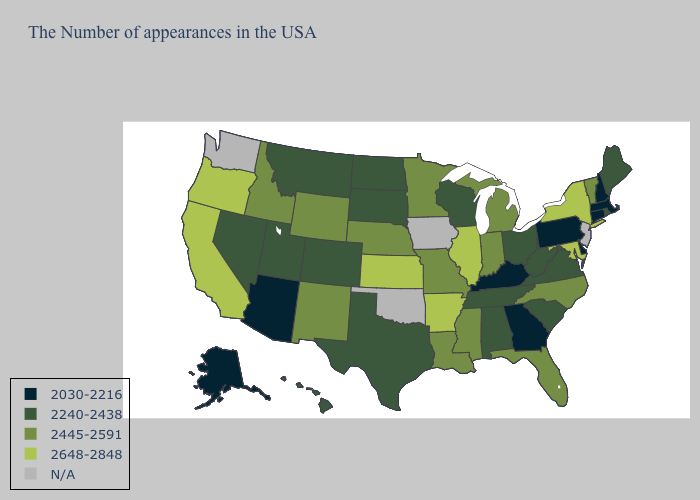What is the value of Arkansas?
Keep it brief. 2648-2848. Does Delaware have the lowest value in the USA?
Be succinct. Yes. Does Pennsylvania have the lowest value in the Northeast?
Write a very short answer. Yes. Which states have the lowest value in the USA?
Write a very short answer. Massachusetts, New Hampshire, Connecticut, Delaware, Pennsylvania, Georgia, Kentucky, Arizona, Alaska. Name the states that have a value in the range 2648-2848?
Concise answer only. New York, Maryland, Illinois, Arkansas, Kansas, California, Oregon. What is the value of Oregon?
Be succinct. 2648-2848. Does Delaware have the lowest value in the South?
Short answer required. Yes. What is the value of Kentucky?
Be succinct. 2030-2216. What is the value of Illinois?
Quick response, please. 2648-2848. What is the lowest value in states that border Maine?
Answer briefly. 2030-2216. Among the states that border Maryland , does West Virginia have the lowest value?
Short answer required. No. What is the lowest value in states that border New York?
Quick response, please. 2030-2216. Does the first symbol in the legend represent the smallest category?
Keep it brief. Yes. Which states have the lowest value in the MidWest?
Keep it brief. Ohio, Wisconsin, South Dakota, North Dakota. Which states have the highest value in the USA?
Give a very brief answer. New York, Maryland, Illinois, Arkansas, Kansas, California, Oregon. 